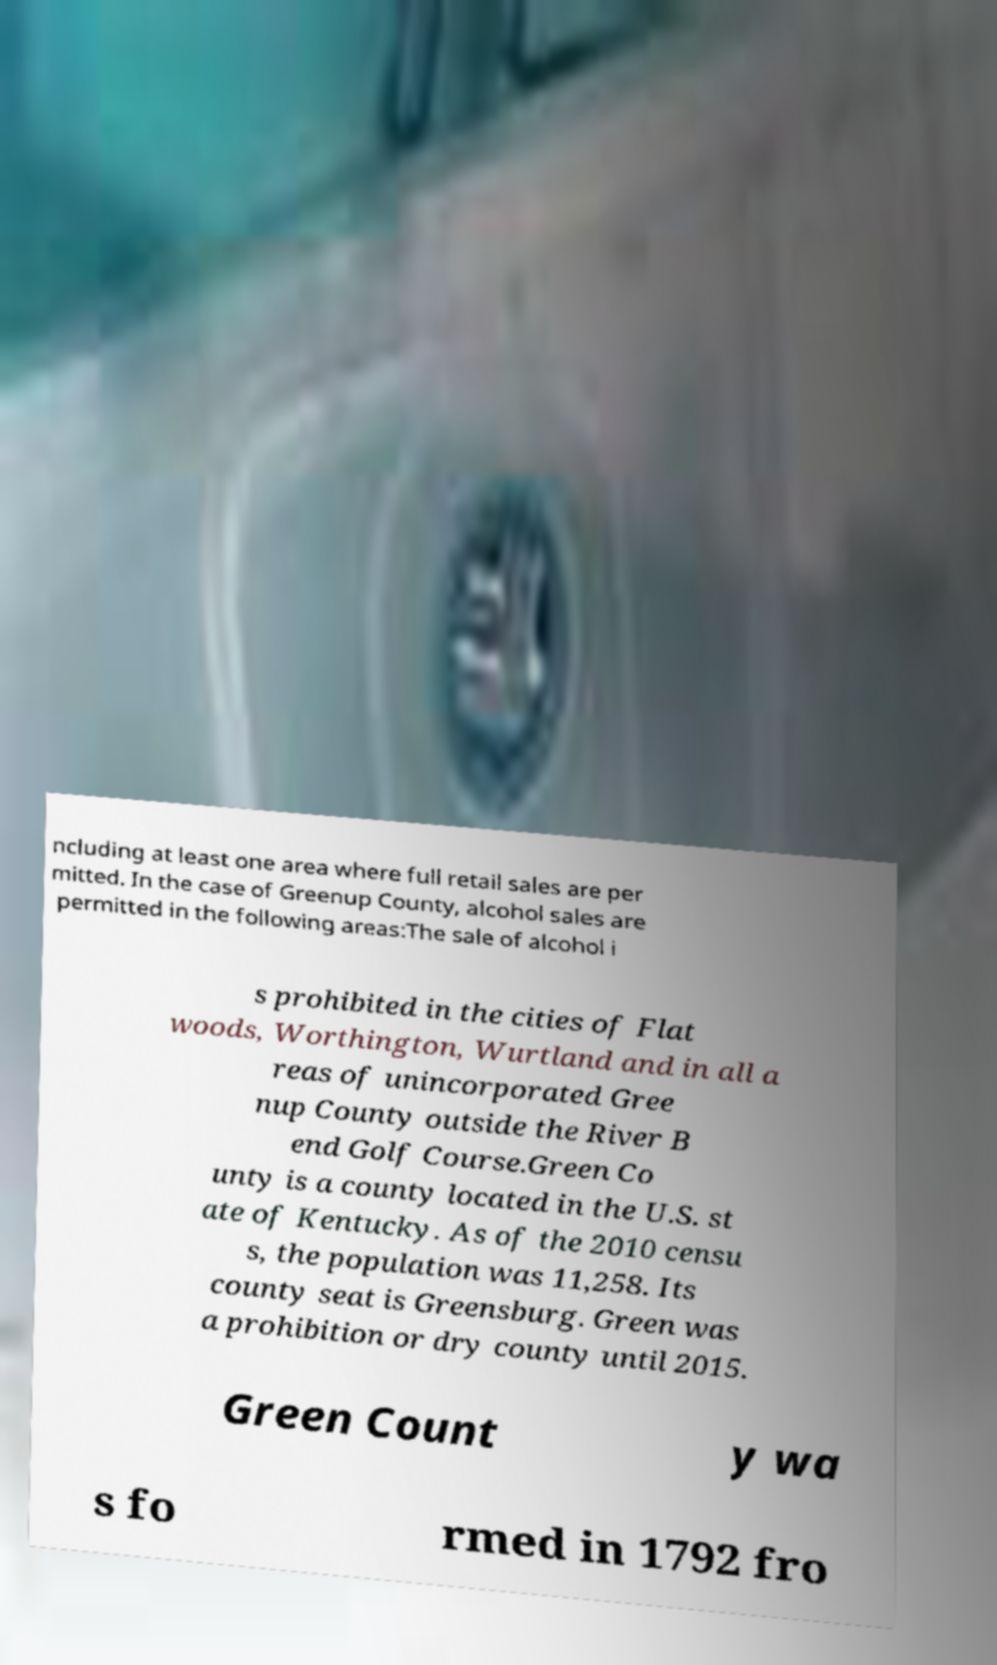Could you extract and type out the text from this image? ncluding at least one area where full retail sales are per mitted. In the case of Greenup County, alcohol sales are permitted in the following areas:The sale of alcohol i s prohibited in the cities of Flat woods, Worthington, Wurtland and in all a reas of unincorporated Gree nup County outside the River B end Golf Course.Green Co unty is a county located in the U.S. st ate of Kentucky. As of the 2010 censu s, the population was 11,258. Its county seat is Greensburg. Green was a prohibition or dry county until 2015. Green Count y wa s fo rmed in 1792 fro 